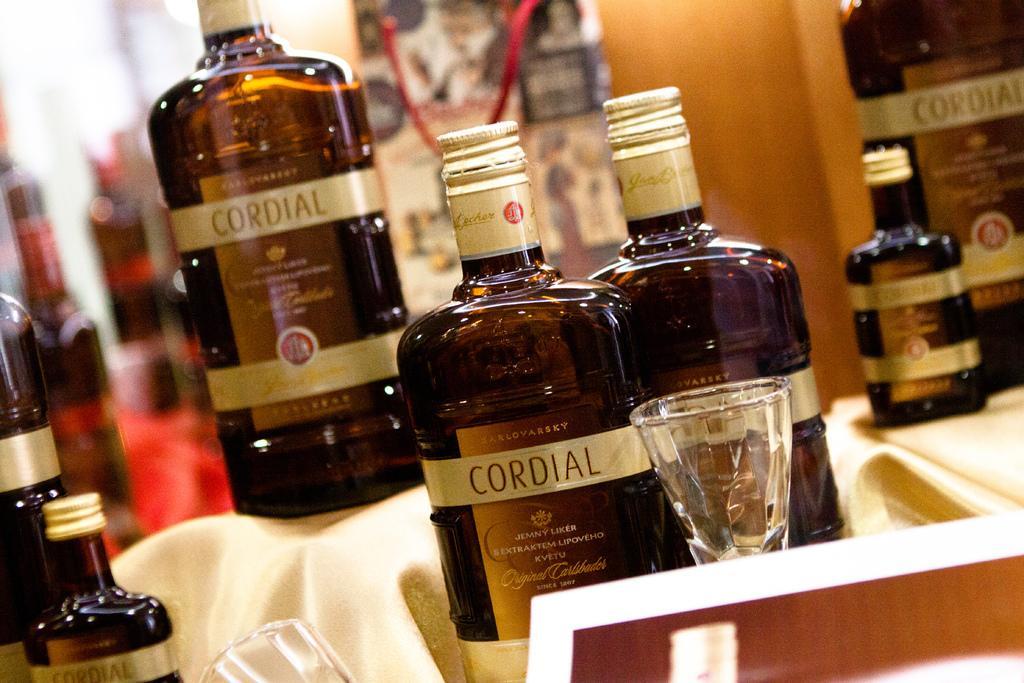How would you summarize this image in a sentence or two? In this image I can see number of bottles and few glasses. 